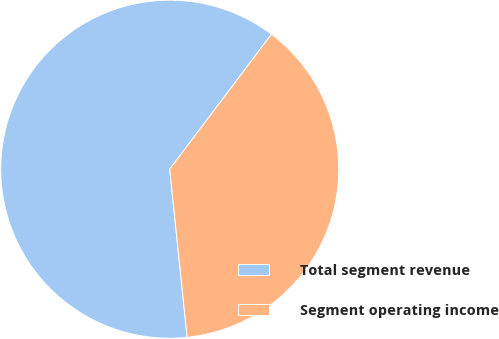Convert chart to OTSL. <chart><loc_0><loc_0><loc_500><loc_500><pie_chart><fcel>Total segment revenue<fcel>Segment operating income<nl><fcel>61.93%<fcel>38.07%<nl></chart> 